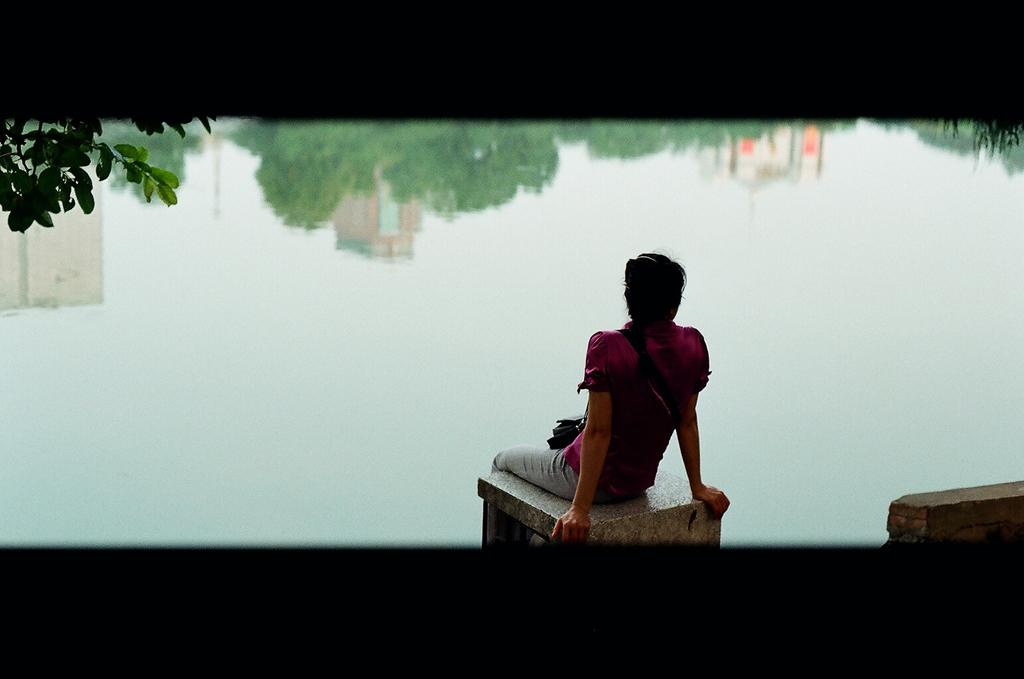What is the person in the image doing? The person is sitting in the image. What is the person wearing? The person is wearing clothes. What can be seen in the background of the image? There is water, leaves, and reflections of the sky, trees, and buildings visible in the image. What type of pear is being served with the wine in the image? There is no pear or wine present in the image. 